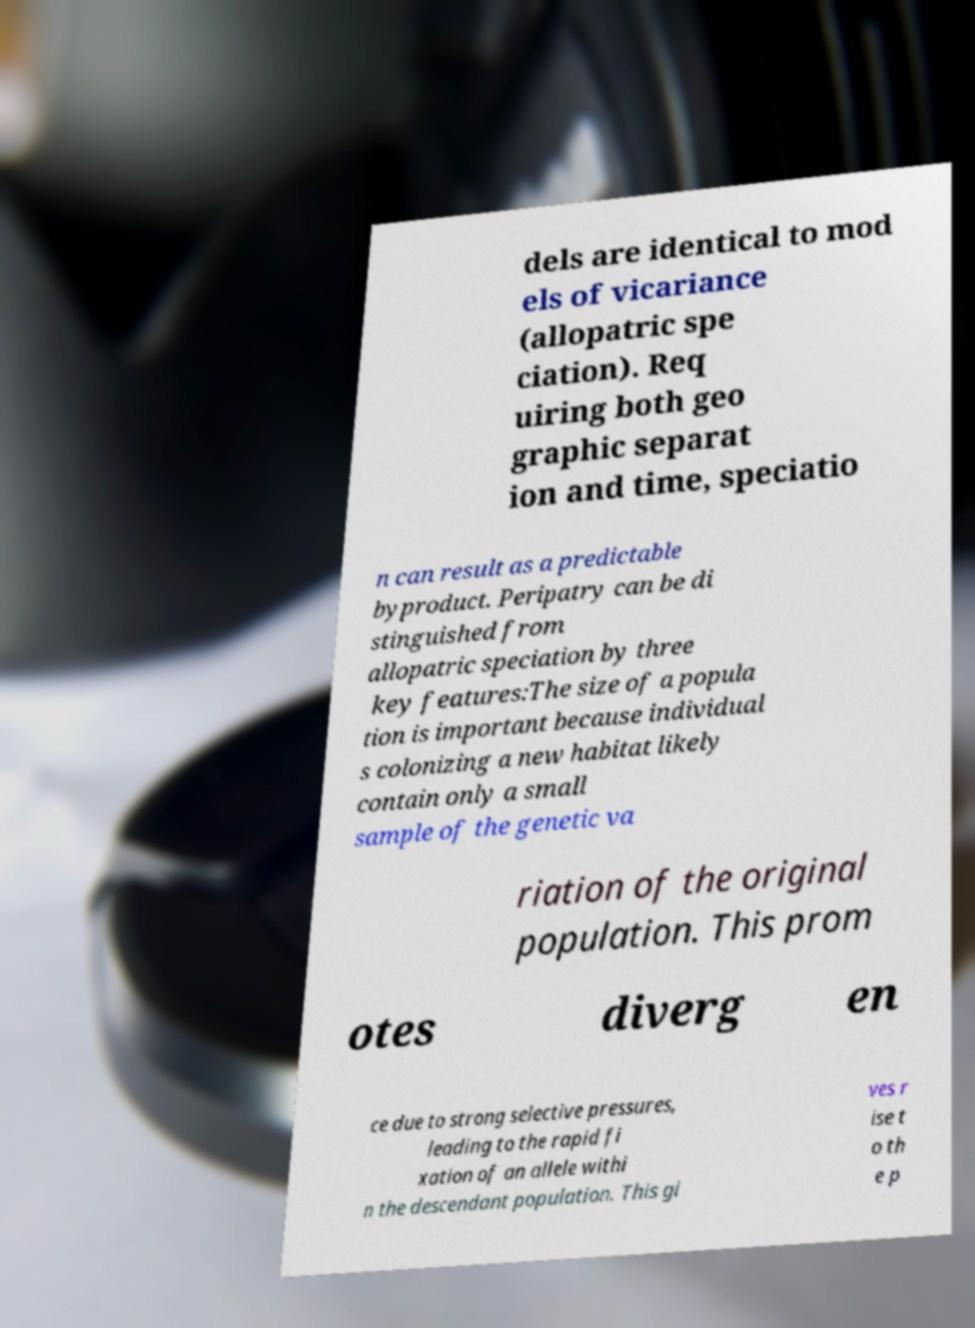What messages or text are displayed in this image? I need them in a readable, typed format. dels are identical to mod els of vicariance (allopatric spe ciation). Req uiring both geo graphic separat ion and time, speciatio n can result as a predictable byproduct. Peripatry can be di stinguished from allopatric speciation by three key features:The size of a popula tion is important because individual s colonizing a new habitat likely contain only a small sample of the genetic va riation of the original population. This prom otes diverg en ce due to strong selective pressures, leading to the rapid fi xation of an allele withi n the descendant population. This gi ves r ise t o th e p 